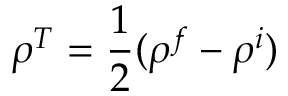Convert formula to latex. <formula><loc_0><loc_0><loc_500><loc_500>\rho ^ { T } = \frac { 1 } { 2 } ( \rho ^ { f } - \rho ^ { i } )</formula> 